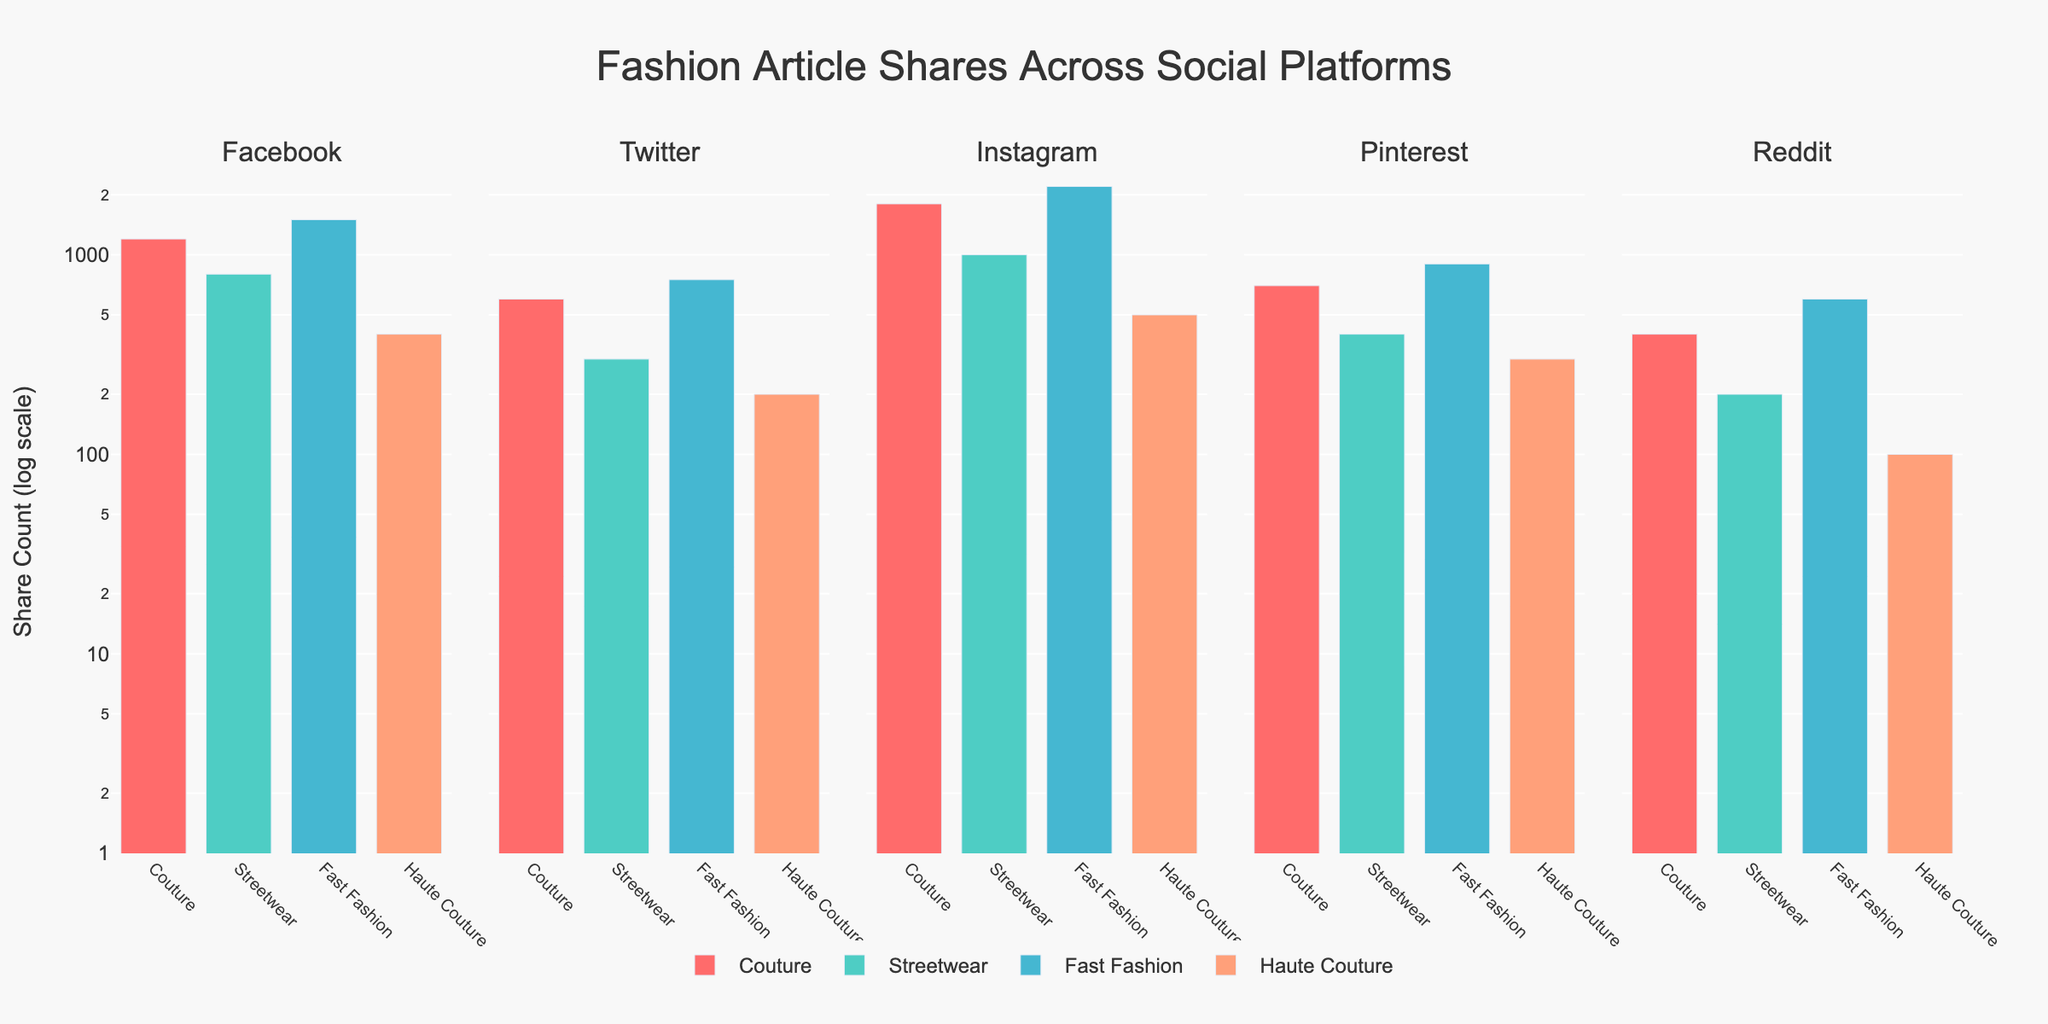What is the title of the figure? The figure's title is prominently displayed at the top, indicating the main topic of the visual representation. The title is "Fashion Article Shares Across Social Platforms."
Answer: Fashion Article Shares Across Social Platforms Which color represents "Couture" articles across all platforms? Each article type is represented by a specific color in the bars. The color for "Couture" is a shade of red (#FF6B6B).
Answer: Red What is the platform with the highest share count for "Fast Fashion" articles? Comparing the heights of the "Fast Fashion" bars across all platforms, Instagram has the highest share count.
Answer: Instagram How many article types are shown for each platform? The x-axis has one bar for each article type, and there are four distinct bars for each platform.
Answer: 4 Which platform has the lowest share count for "Haute Couture" articles, and what is the value? By looking at the smallest bar height for "Haute Couture" articles, Reddit has the lowest share count at 100.
Answer: Reddit, 100 Rank the platforms from highest to lowest total share counts for "Streetwear" articles. Sum the share counts for "Streetwear" on each platform: Instagram (1000), Facebook (800), Pinterest (400), Twitter (300), Reddit (200).
Answer: Instagram > Facebook > Pinterest > Twitter > Reddit What is the sum of share counts for "Couture" articles across all platforms? Adding the share counts from all platforms for "Couture": Facebook (1200), Twitter (600), Instagram (1800), Pinterest (700), Reddit (400). So, 1200 + 600 + 1800 + 700 + 400 = 4700.
Answer: 4700 Which platform has the most even distribution of shares across all article types? By comparing the bar heights for all article types on each platform, Pinterest has the most even distribution since the differences among bars are relatively small.
Answer: Pinterest 